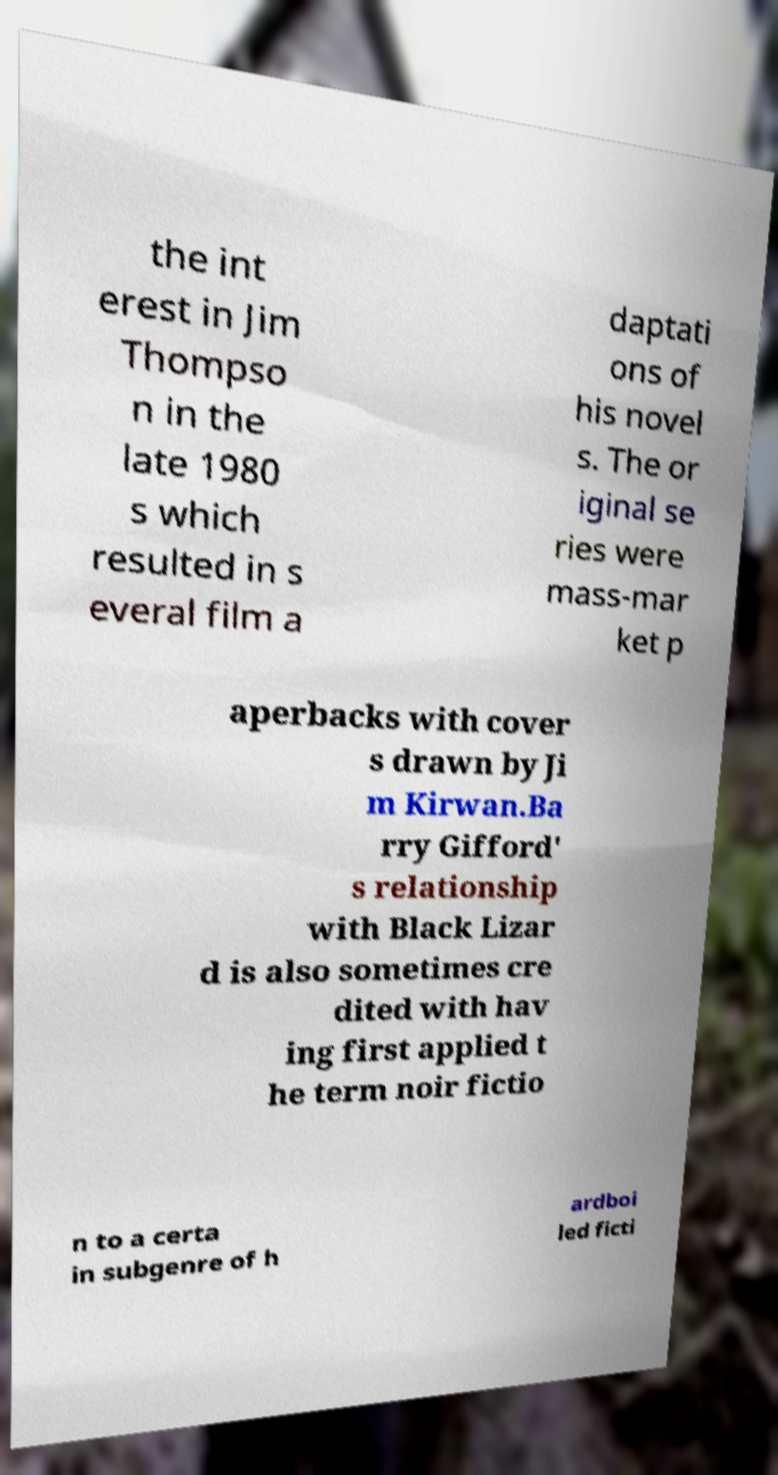Please identify and transcribe the text found in this image. the int erest in Jim Thompso n in the late 1980 s which resulted in s everal film a daptati ons of his novel s. The or iginal se ries were mass-mar ket p aperbacks with cover s drawn by Ji m Kirwan.Ba rry Gifford' s relationship with Black Lizar d is also sometimes cre dited with hav ing first applied t he term noir fictio n to a certa in subgenre of h ardboi led ficti 